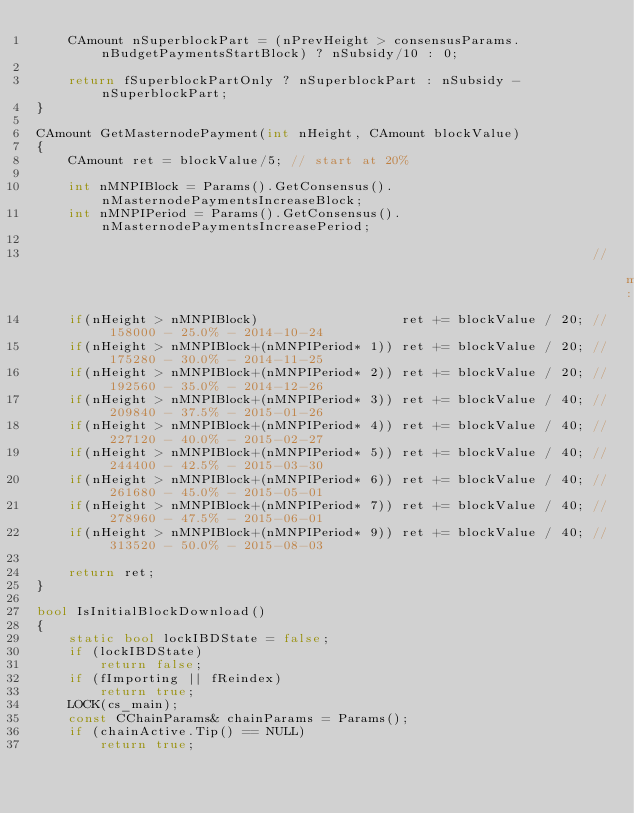<code> <loc_0><loc_0><loc_500><loc_500><_C++_>    CAmount nSuperblockPart = (nPrevHeight > consensusParams.nBudgetPaymentsStartBlock) ? nSubsidy/10 : 0;

    return fSuperblockPartOnly ? nSuperblockPart : nSubsidy - nSuperblockPart;
}

CAmount GetMasternodePayment(int nHeight, CAmount blockValue)
{
    CAmount ret = blockValue/5; // start at 20%

    int nMNPIBlock = Params().GetConsensus().nMasternodePaymentsIncreaseBlock;
    int nMNPIPeriod = Params().GetConsensus().nMasternodePaymentsIncreasePeriod;

                                                                      // mainnet:
    if(nHeight > nMNPIBlock)                  ret += blockValue / 20; // 158000 - 25.0% - 2014-10-24
    if(nHeight > nMNPIBlock+(nMNPIPeriod* 1)) ret += blockValue / 20; // 175280 - 30.0% - 2014-11-25
    if(nHeight > nMNPIBlock+(nMNPIPeriod* 2)) ret += blockValue / 20; // 192560 - 35.0% - 2014-12-26
    if(nHeight > nMNPIBlock+(nMNPIPeriod* 3)) ret += blockValue / 40; // 209840 - 37.5% - 2015-01-26
    if(nHeight > nMNPIBlock+(nMNPIPeriod* 4)) ret += blockValue / 40; // 227120 - 40.0% - 2015-02-27
    if(nHeight > nMNPIBlock+(nMNPIPeriod* 5)) ret += blockValue / 40; // 244400 - 42.5% - 2015-03-30
    if(nHeight > nMNPIBlock+(nMNPIPeriod* 6)) ret += blockValue / 40; // 261680 - 45.0% - 2015-05-01
    if(nHeight > nMNPIBlock+(nMNPIPeriod* 7)) ret += blockValue / 40; // 278960 - 47.5% - 2015-06-01
    if(nHeight > nMNPIBlock+(nMNPIPeriod* 9)) ret += blockValue / 40; // 313520 - 50.0% - 2015-08-03

    return ret;
}

bool IsInitialBlockDownload()
{
    static bool lockIBDState = false;
    if (lockIBDState)
        return false;
    if (fImporting || fReindex)
        return true;
    LOCK(cs_main);
    const CChainParams& chainParams = Params();
    if (chainActive.Tip() == NULL)
        return true;</code> 